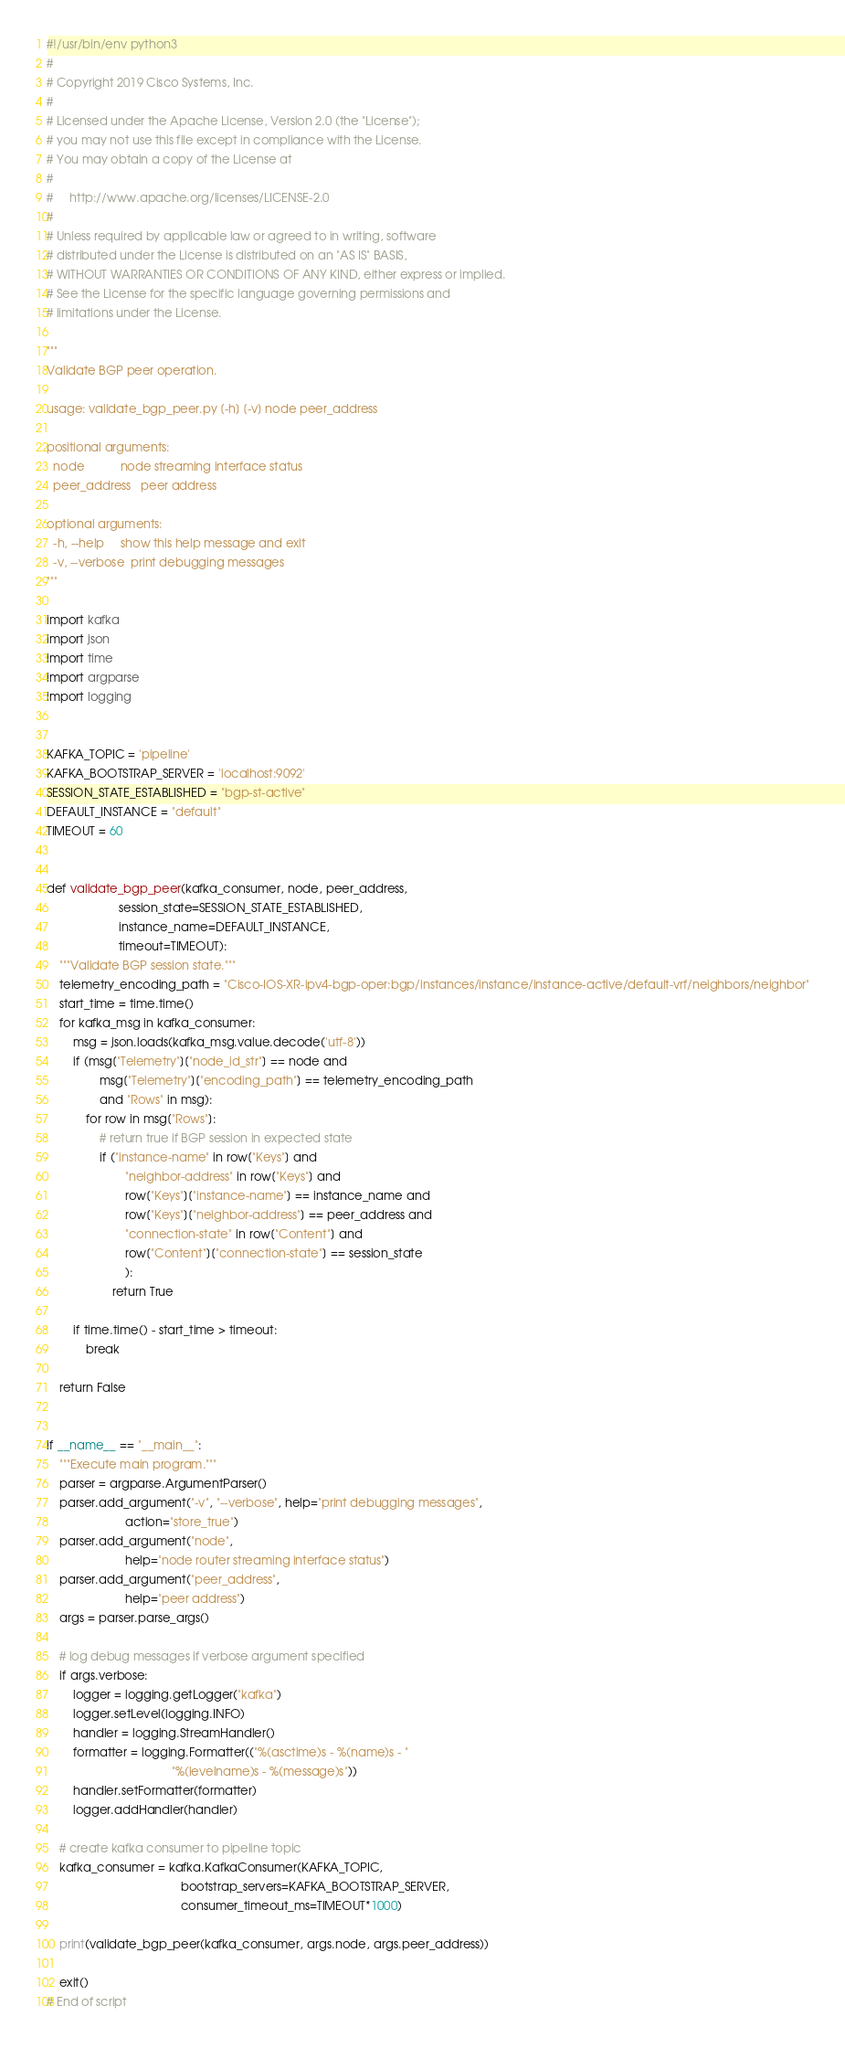Convert code to text. <code><loc_0><loc_0><loc_500><loc_500><_Python_>#!/usr/bin/env python3
#
# Copyright 2019 Cisco Systems, Inc.
#
# Licensed under the Apache License, Version 2.0 (the "License");
# you may not use this file except in compliance with the License.
# You may obtain a copy of the License at
#
#     http://www.apache.org/licenses/LICENSE-2.0
#
# Unless required by applicable law or agreed to in writing, software
# distributed under the License is distributed on an "AS IS" BASIS,
# WITHOUT WARRANTIES OR CONDITIONS OF ANY KIND, either express or implied.
# See the License for the specific language governing permissions and
# limitations under the License.

"""
Validate BGP peer operation.

usage: validate_bgp_peer.py [-h] [-v] node peer_address

positional arguments:
  node           node streaming interface status
  peer_address   peer address

optional arguments:
  -h, --help     show this help message and exit
  -v, --verbose  print debugging messages
"""

import kafka
import json
import time
import argparse
import logging


KAFKA_TOPIC = 'pipeline'
KAFKA_BOOTSTRAP_SERVER = 'localhost:9092'
SESSION_STATE_ESTABLISHED = "bgp-st-active"
DEFAULT_INSTANCE = "default"
TIMEOUT = 60


def validate_bgp_peer(kafka_consumer, node, peer_address,
                      session_state=SESSION_STATE_ESTABLISHED,
                      instance_name=DEFAULT_INSTANCE,
                      timeout=TIMEOUT):
    """Validate BGP session state."""
    telemetry_encoding_path = "Cisco-IOS-XR-ipv4-bgp-oper:bgp/instances/instance/instance-active/default-vrf/neighbors/neighbor"
    start_time = time.time()
    for kafka_msg in kafka_consumer:
        msg = json.loads(kafka_msg.value.decode('utf-8'))
        if (msg["Telemetry"]["node_id_str"] == node and
                msg["Telemetry"]["encoding_path"] == telemetry_encoding_path
                and "Rows" in msg):
            for row in msg["Rows"]:
                # return true if BGP session in expected state
                if ("instance-name" in row["Keys"] and
                        "neighbor-address" in row["Keys"] and
                        row["Keys"]["instance-name"] == instance_name and
                        row["Keys"]["neighbor-address"] == peer_address and
                        "connection-state" in row["Content"] and
                        row["Content"]["connection-state"] == session_state
                        ):
                    return True

        if time.time() - start_time > timeout:
            break

    return False


if __name__ == "__main__":
    """Execute main program."""
    parser = argparse.ArgumentParser()
    parser.add_argument("-v", "--verbose", help="print debugging messages",
                        action="store_true")
    parser.add_argument("node",
                        help="node router streaming interface status")
    parser.add_argument("peer_address",
                        help="peer address")
    args = parser.parse_args()

    # log debug messages if verbose argument specified
    if args.verbose:
        logger = logging.getLogger("kafka")
        logger.setLevel(logging.INFO)
        handler = logging.StreamHandler()
        formatter = logging.Formatter(("%(asctime)s - %(name)s - "
                                      "%(levelname)s - %(message)s"))
        handler.setFormatter(formatter)
        logger.addHandler(handler)

    # create kafka consumer to pipeline topic
    kafka_consumer = kafka.KafkaConsumer(KAFKA_TOPIC,
                                         bootstrap_servers=KAFKA_BOOTSTRAP_SERVER,
                                         consumer_timeout_ms=TIMEOUT*1000)

    print(validate_bgp_peer(kafka_consumer, args.node, args.peer_address))

    exit()
# End of script
</code> 